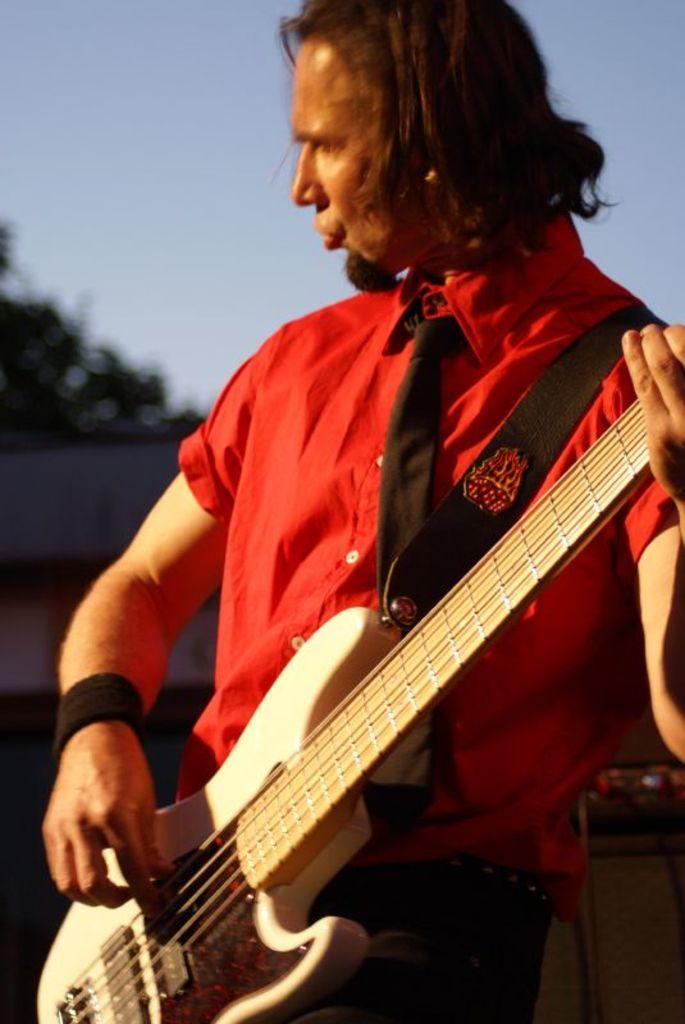What is the main subject of the image? There is a person in the image. What is the person holding in the image? The person is holding a guitar. What can be seen in the background of the image? There is a sky visible in the background of the image. What advice does the person in the image give to the island? There is no island present in the image, and therefore no advice can be given to it. 